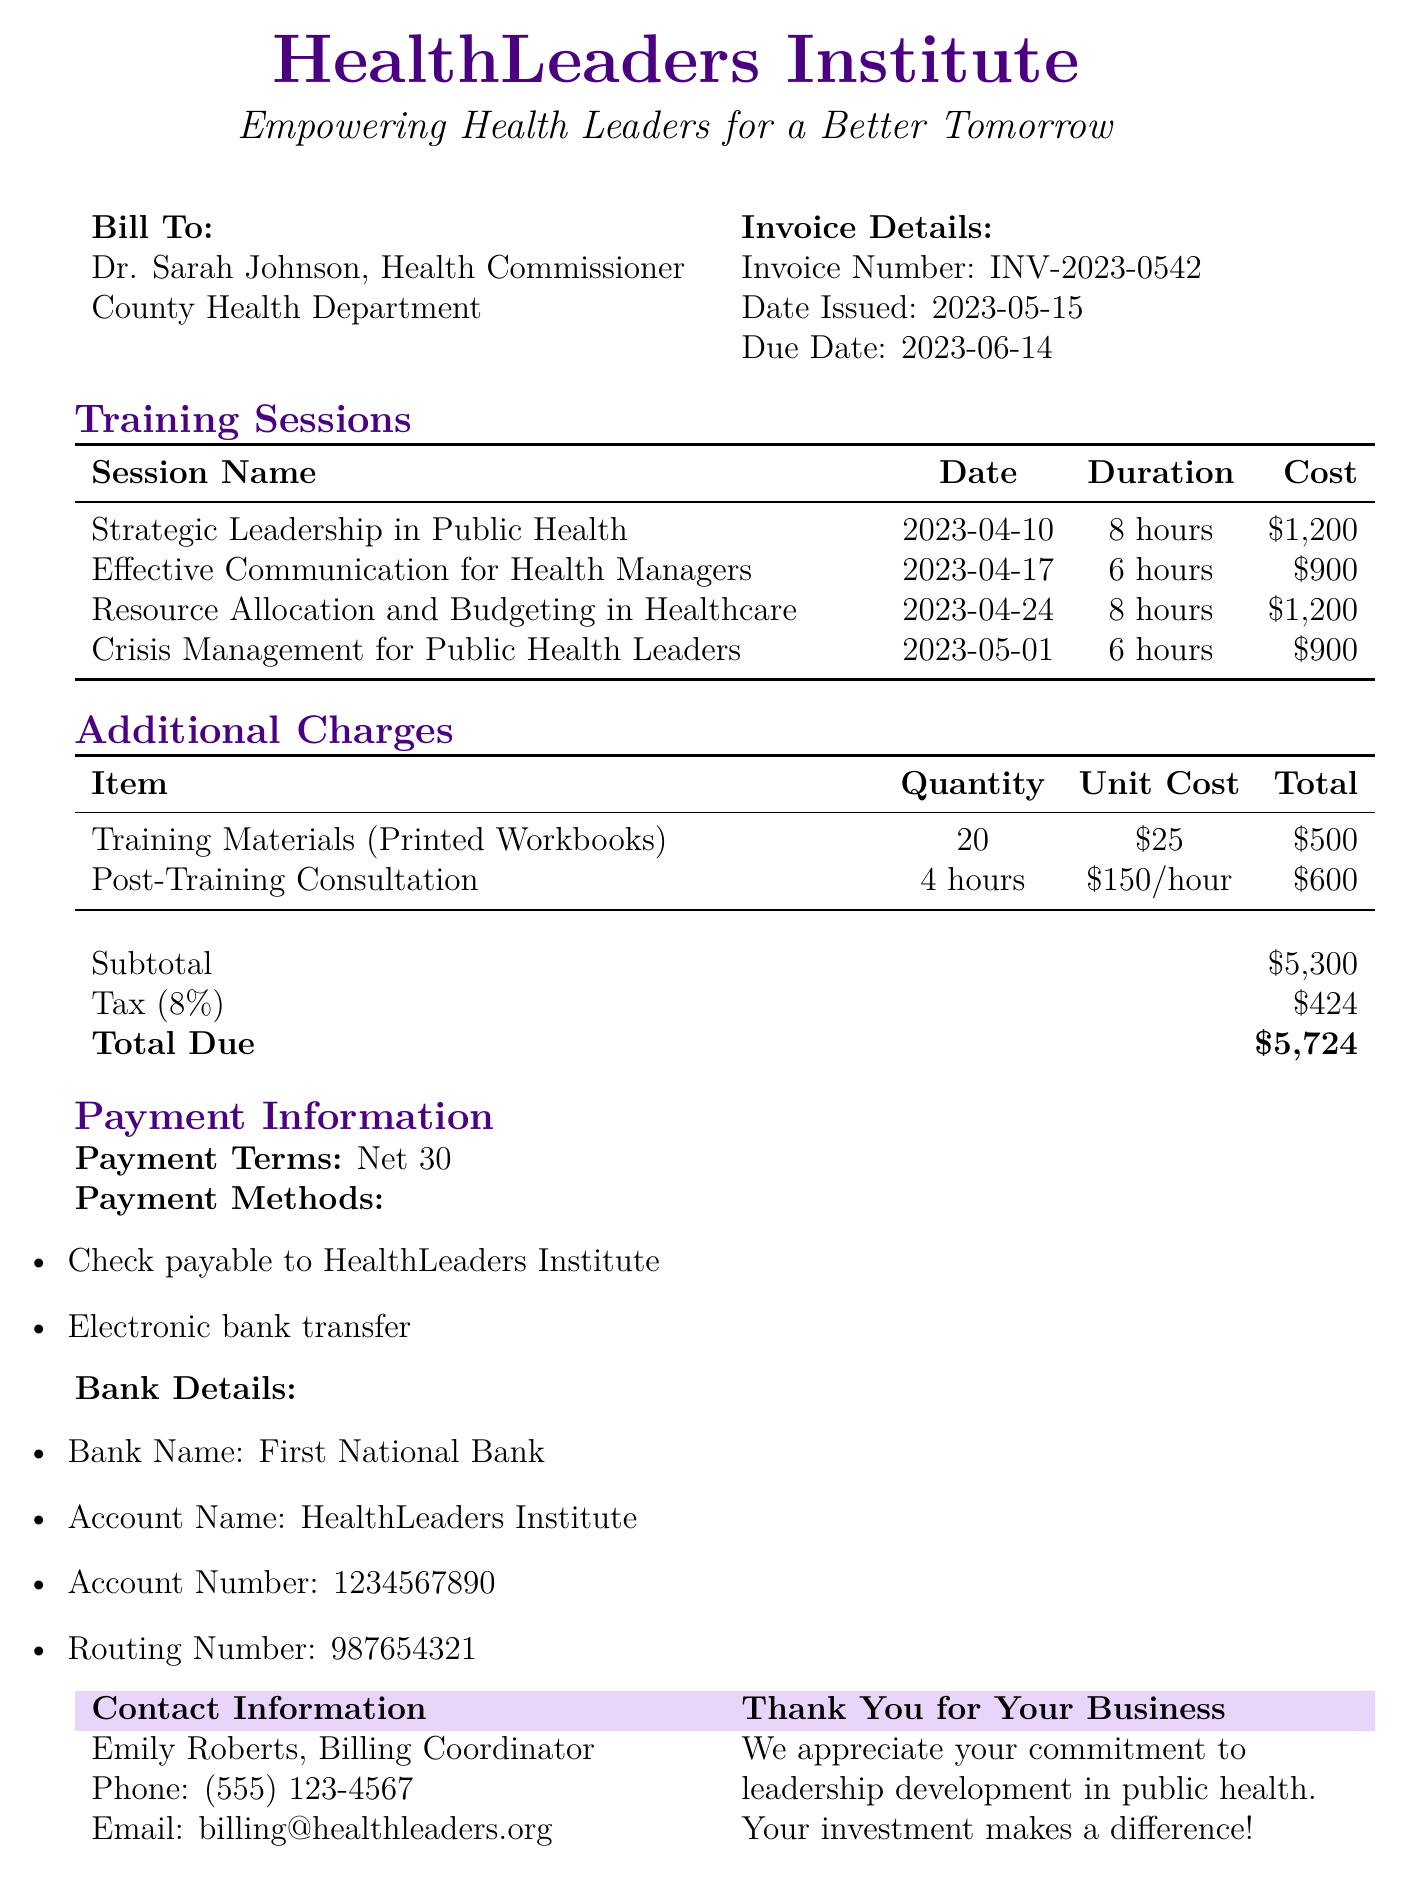What is the invoice number? The invoice number is mentioned in the document details section.
Answer: INV-2023-0542 Who is the billed entity? The document indicates the person and their organization being billed.
Answer: Dr. Sarah Johnson, County Health Department What is the total due amount? The total due amount is calculated from the subtotal and tax provided in the document.
Answer: $5,724 How many hours is the 'Crisis Management for Public Health Leaders' session? The duration for the specific training session can be found in the training sessions table.
Answer: 6 hours What is the cost of training materials? The cost of the training materials is provided in the additional charges section of the document.
Answer: $500 What method of payment is offered alongside checks? The document lists various payment methods, including electronic transactions.
Answer: Electronic bank transfer What is the due date for the invoice? The due date is specified in the invoice details section of the bill.
Answer: 2023-06-14 How many training sessions are listed? The total number of training sessions can be counted from the training sessions table in the document.
Answer: 4 sessions What is the tax percentage applied to the invoice? The tax percentage is explicitly mentioned in the document calculations.
Answer: 8% 